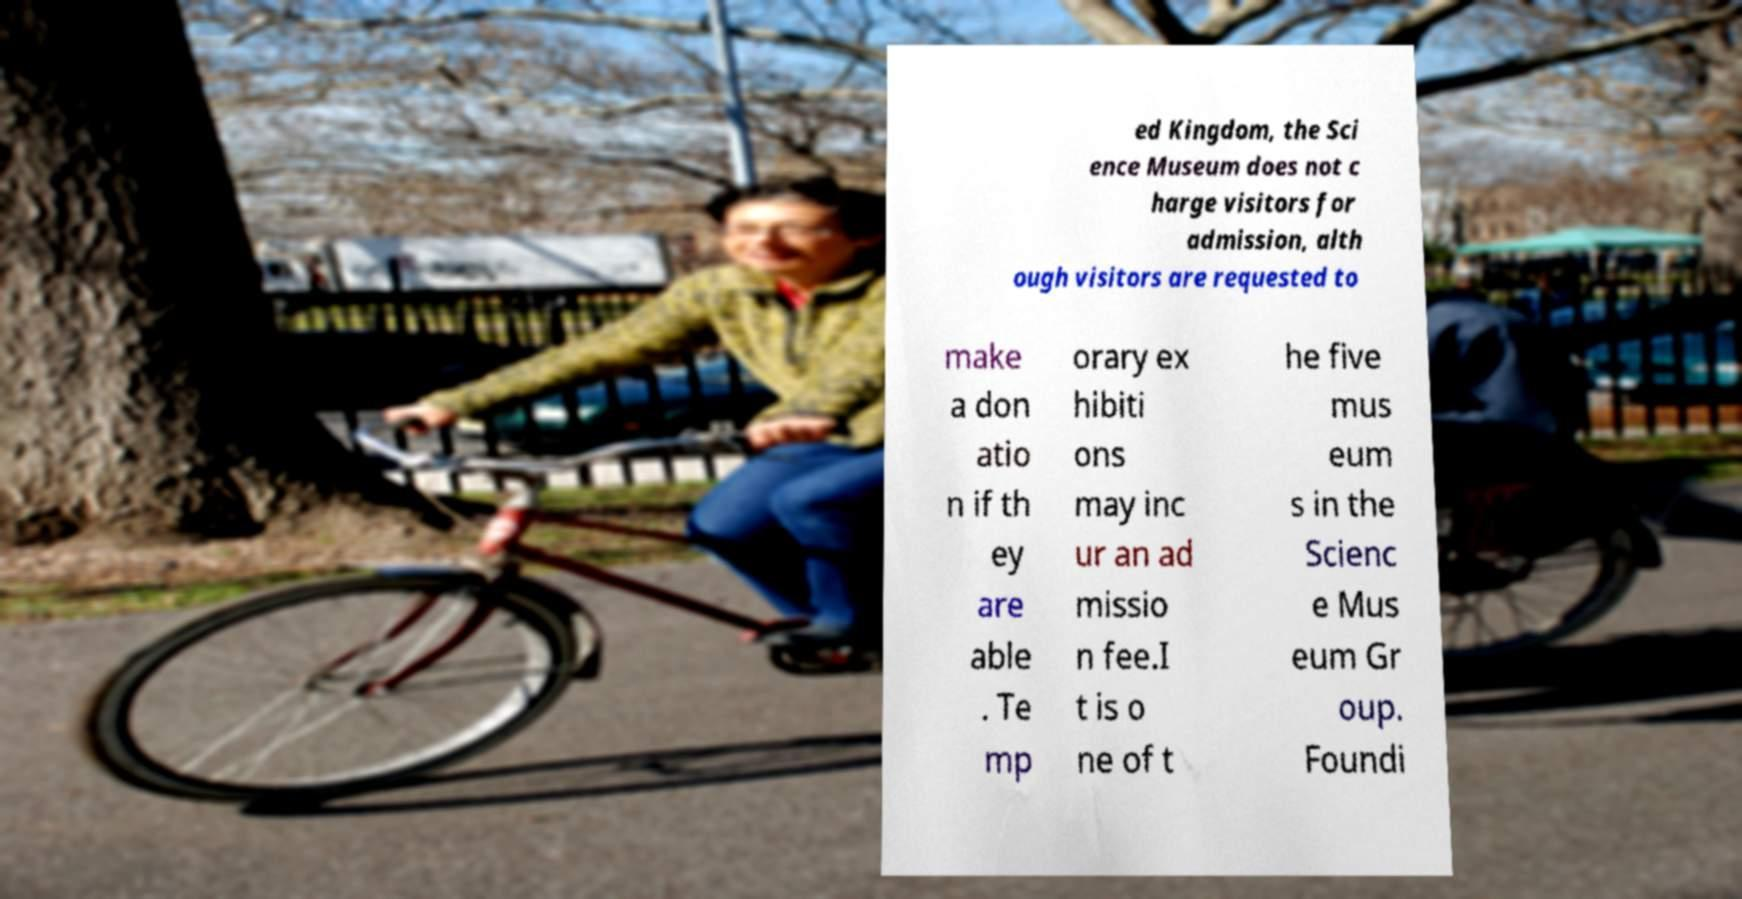What messages or text are displayed in this image? I need them in a readable, typed format. ed Kingdom, the Sci ence Museum does not c harge visitors for admission, alth ough visitors are requested to make a don atio n if th ey are able . Te mp orary ex hibiti ons may inc ur an ad missio n fee.I t is o ne of t he five mus eum s in the Scienc e Mus eum Gr oup. Foundi 